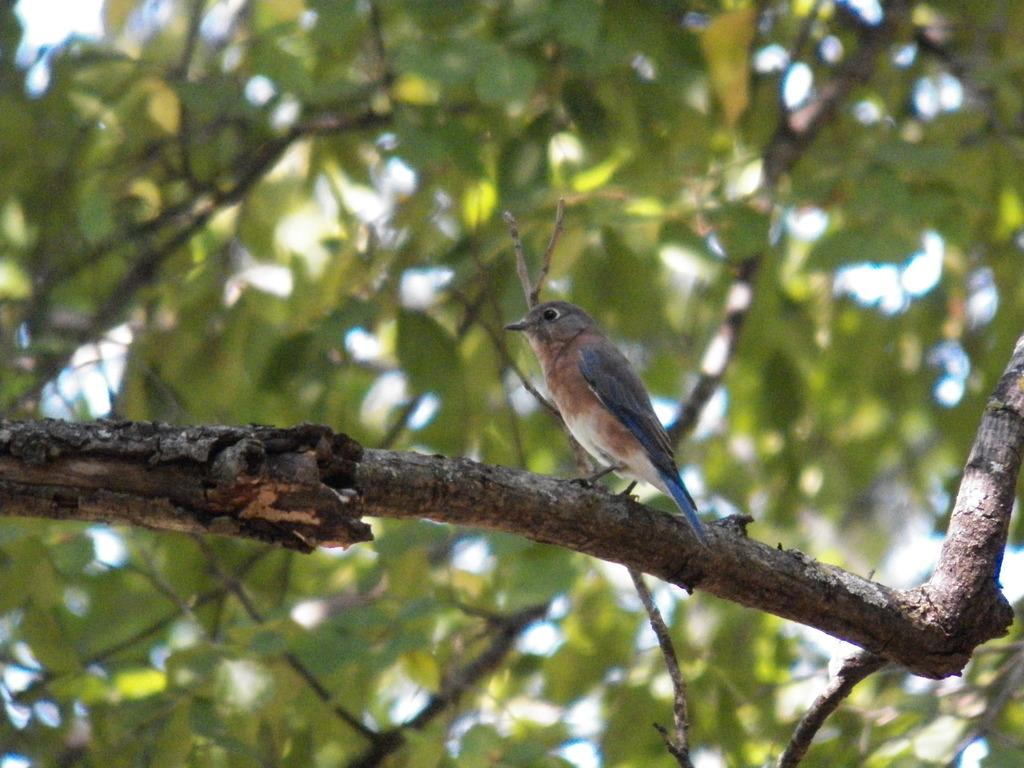What type of animal is in the image? There is a bird in the image. Where is the bird located? The bird is on a branch. What can be seen in the background of the image? The background of the image is green and blurry. What type of flower is the bird holding in its beak in the image? There is no flower present in the image, and the bird is not holding anything in its beak. 